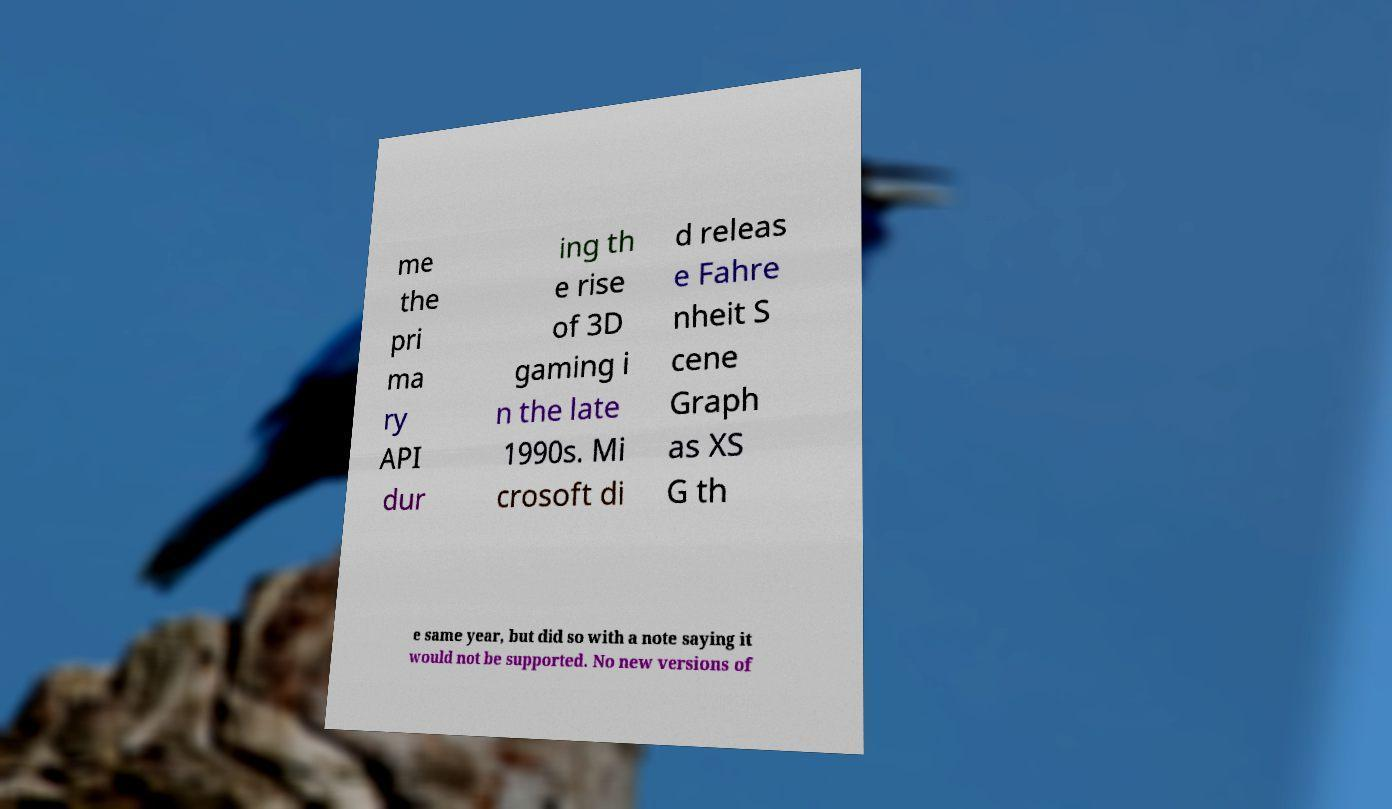Could you extract and type out the text from this image? me the pri ma ry API dur ing th e rise of 3D gaming i n the late 1990s. Mi crosoft di d releas e Fahre nheit S cene Graph as XS G th e same year, but did so with a note saying it would not be supported. No new versions of 